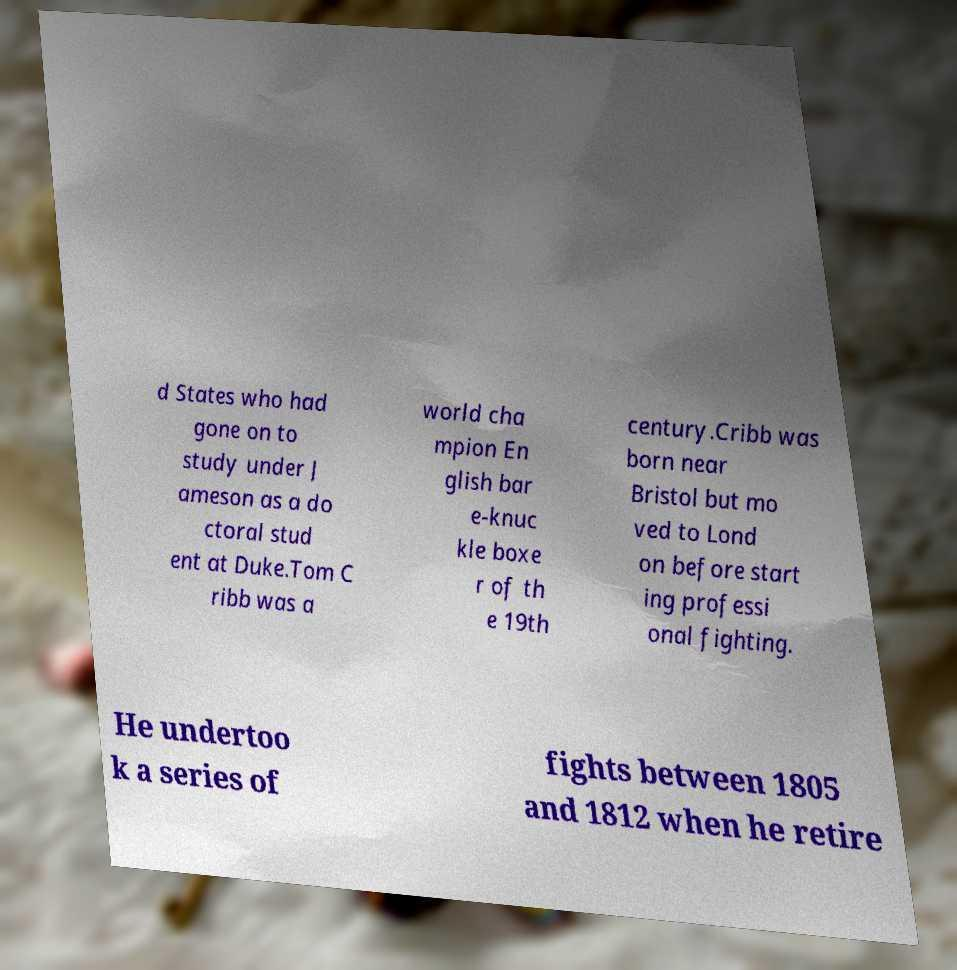What messages or text are displayed in this image? I need them in a readable, typed format. d States who had gone on to study under J ameson as a do ctoral stud ent at Duke.Tom C ribb was a world cha mpion En glish bar e-knuc kle boxe r of th e 19th century.Cribb was born near Bristol but mo ved to Lond on before start ing professi onal fighting. He undertoo k a series of fights between 1805 and 1812 when he retire 